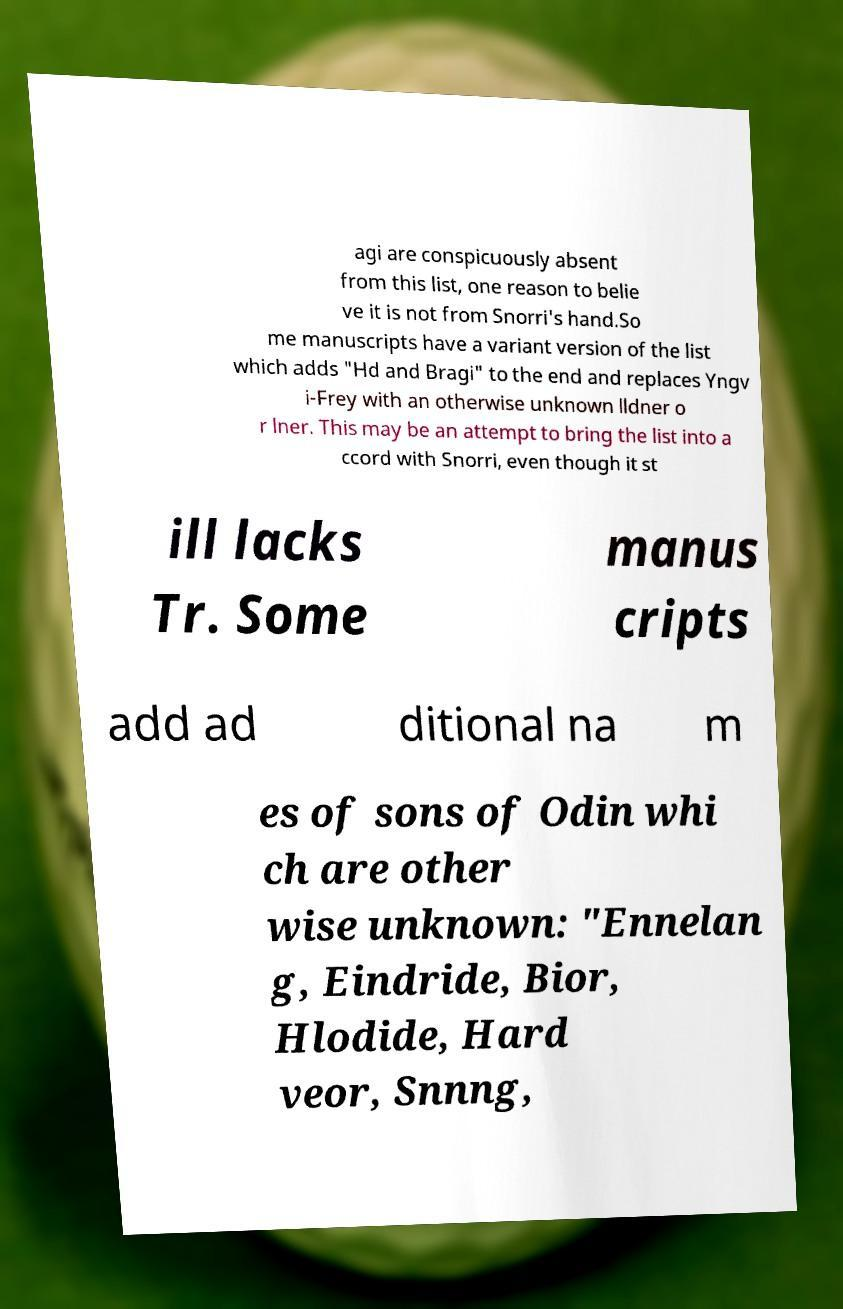I need the written content from this picture converted into text. Can you do that? agi are conspicuously absent from this list, one reason to belie ve it is not from Snorri's hand.So me manuscripts have a variant version of the list which adds "Hd and Bragi" to the end and replaces Yngv i-Frey with an otherwise unknown lldner o r lner. This may be an attempt to bring the list into a ccord with Snorri, even though it st ill lacks Tr. Some manus cripts add ad ditional na m es of sons of Odin whi ch are other wise unknown: "Ennelan g, Eindride, Bior, Hlodide, Hard veor, Snnng, 